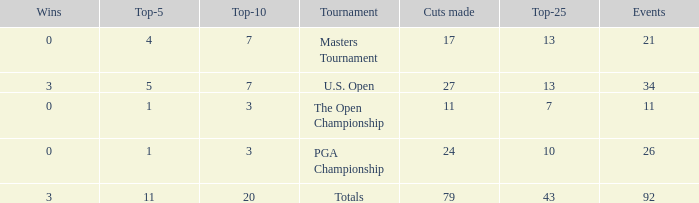Name the sum of top-25 for pga championship and top-5 less than 1 None. 